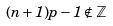<formula> <loc_0><loc_0><loc_500><loc_500>( n + 1 ) p - 1 \notin \mathbb { Z }</formula> 